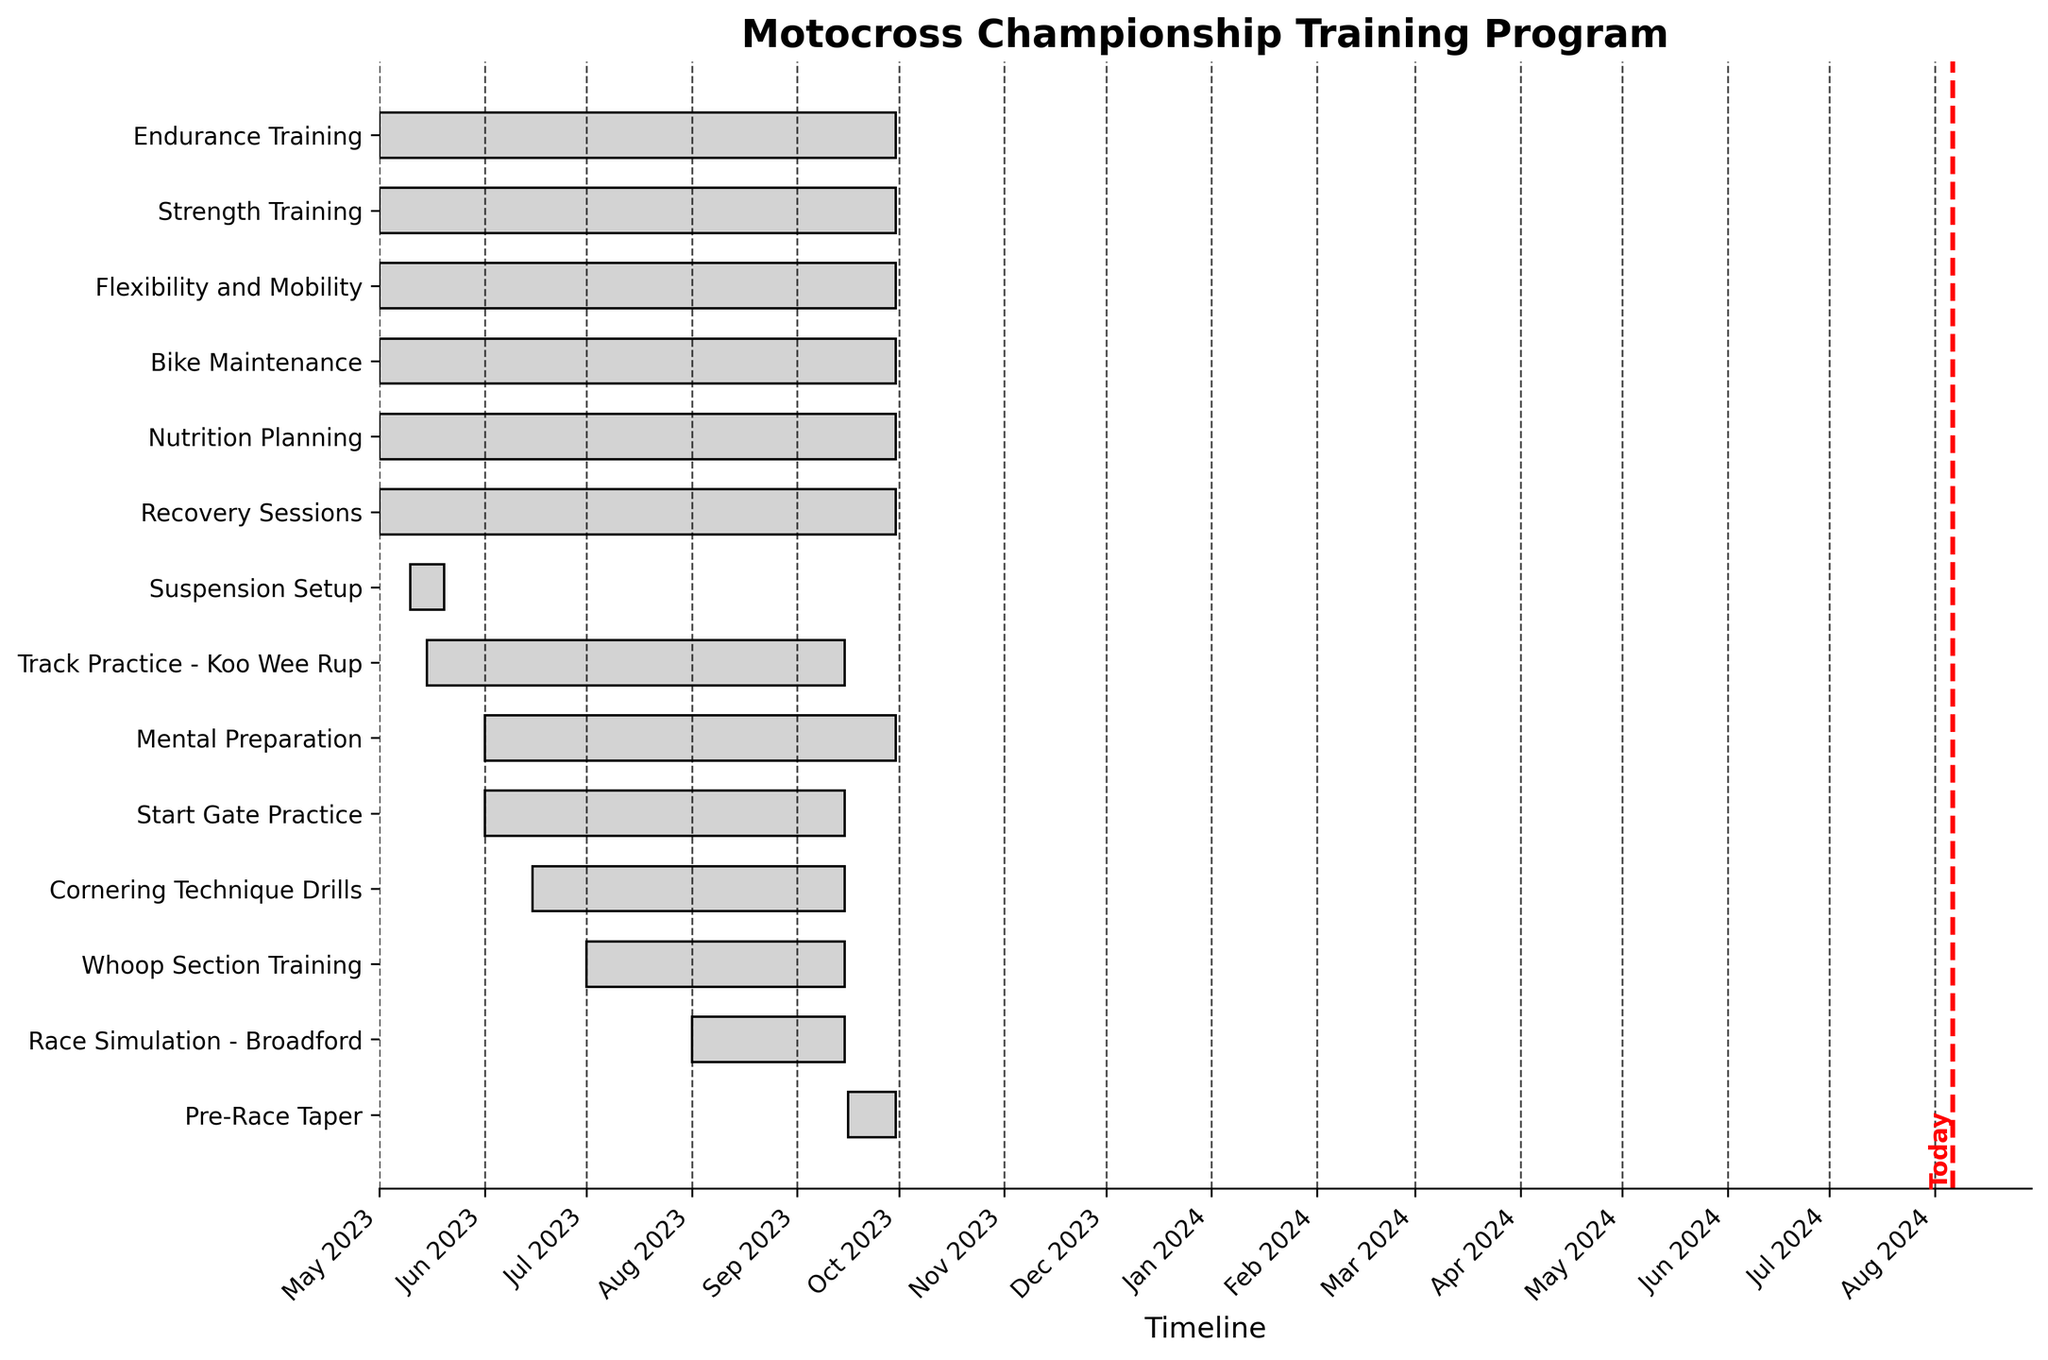what is the title of the Gantt Chart? The title can be seen at the top of the Gantt Chart. It provides a brief description of what the chart is about.
Answer: Motocross Championship Training Program How many training tasks start in June? By observing the starting dates on the Gantt Chart, count the tasks that begin in the month labeled 'Jun'.
Answer: 3 When does the 'Cornering Technique Drills' task start and end? Look for the 'Cornering Technique Drills' label on the y-axis and then trace the corresponding horizontal bar to find its start and end dates.
Answer: Jun 15, 2023 - Sep 15, 2023 Which task has the shortest duration? Compare the lengths of all horizontal bars representing the tasks to identify the one with the shortest span.
Answer: Suspension Setup What are the start and end dates of the 'Race Simulation - Broadford' task? Locate the 'Race Simulation - Broadford' label on the y-axis and trace the corresponding horizontal bar to find its start and end dates.
Answer: Aug 1, 2023 - Sep 15, 2023 How many tasks overlap with 'Mental Preparation'? Find the 'Mental Preparation' task, note its duration, and count how many bars span the same time interval or partially overlap with it.
Answer: 11 Which month has the highest number of tasks beginning? By examining the start dates on the Gantt Chart, count the number of tasks beginning in each month and identify the month with the most starts.
Answer: May Which task has the latest end date? Look at the end date of each task on the Gantt Chart to determine which one extends the furthest to the right.
Answer: Pre-Race Taper How long is the 'Endurance Training' task in total days? Calculate the duration by subtracting the start date from the end date of the 'Endurance Training' task.
Answer: 153 days Which tasks are specifically scheduled to run in September for part or all of the month? Identify tasks that have bars extending into or throughout September.
Answer: Endurance Training, Strength Training, Flexibility and Mobility, Track Practice - Koo Wee Rup, Bike Maintenance, Nutrition Planning, Mental Preparation, Recovery Sessions, Start Gate Practice, Cornering Technique Drills, Whoop Section Training, Race Simulation - Broadford, Pre-Race Taper What is marked using a red line? Observe the Gantt Chart for any unique red markers, typically used to indicate an important date such as today's date.
Answer: Today 